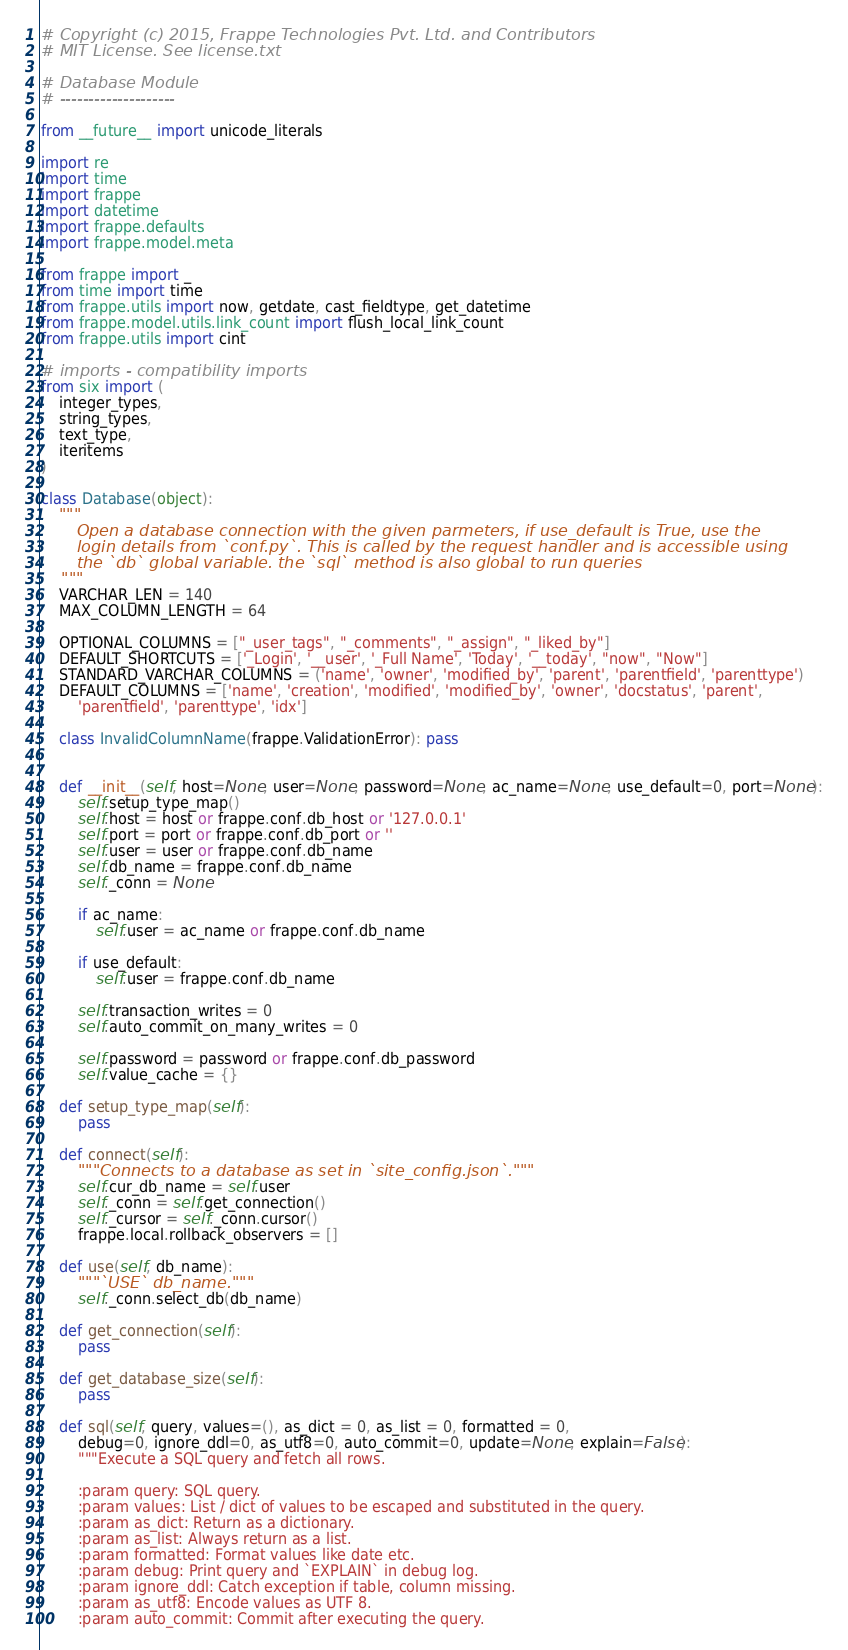Convert code to text. <code><loc_0><loc_0><loc_500><loc_500><_Python_># Copyright (c) 2015, Frappe Technologies Pvt. Ltd. and Contributors
# MIT License. See license.txt

# Database Module
# --------------------

from __future__ import unicode_literals

import re
import time
import frappe
import datetime
import frappe.defaults
import frappe.model.meta

from frappe import _
from time import time
from frappe.utils import now, getdate, cast_fieldtype, get_datetime
from frappe.model.utils.link_count import flush_local_link_count
from frappe.utils import cint

# imports - compatibility imports
from six import (
	integer_types,
	string_types,
	text_type,
	iteritems
)

class Database(object):
	"""
	   Open a database connection with the given parmeters, if use_default is True, use the
	   login details from `conf.py`. This is called by the request handler and is accessible using
	   the `db` global variable. the `sql` method is also global to run queries
	"""
	VARCHAR_LEN = 140
	MAX_COLUMN_LENGTH = 64

	OPTIONAL_COLUMNS = ["_user_tags", "_comments", "_assign", "_liked_by"]
	DEFAULT_SHORTCUTS = ['_Login', '__user', '_Full Name', 'Today', '__today', "now", "Now"]
	STANDARD_VARCHAR_COLUMNS = ('name', 'owner', 'modified_by', 'parent', 'parentfield', 'parenttype')
	DEFAULT_COLUMNS = ['name', 'creation', 'modified', 'modified_by', 'owner', 'docstatus', 'parent',
		'parentfield', 'parenttype', 'idx']

	class InvalidColumnName(frappe.ValidationError): pass


	def __init__(self, host=None, user=None, password=None, ac_name=None, use_default=0, port=None):
		self.setup_type_map()
		self.host = host or frappe.conf.db_host or '127.0.0.1'
		self.port = port or frappe.conf.db_port or ''
		self.user = user or frappe.conf.db_name
		self.db_name = frappe.conf.db_name
		self._conn = None

		if ac_name:
			self.user = ac_name or frappe.conf.db_name

		if use_default:
			self.user = frappe.conf.db_name

		self.transaction_writes = 0
		self.auto_commit_on_many_writes = 0

		self.password = password or frappe.conf.db_password
		self.value_cache = {}

	def setup_type_map(self):
		pass

	def connect(self):
		"""Connects to a database as set in `site_config.json`."""
		self.cur_db_name = self.user
		self._conn = self.get_connection()
		self._cursor = self._conn.cursor()
		frappe.local.rollback_observers = []

	def use(self, db_name):
		"""`USE` db_name."""
		self._conn.select_db(db_name)

	def get_connection(self):
		pass

	def get_database_size(self):
		pass

	def sql(self, query, values=(), as_dict = 0, as_list = 0, formatted = 0,
		debug=0, ignore_ddl=0, as_utf8=0, auto_commit=0, update=None, explain=False):
		"""Execute a SQL query and fetch all rows.

		:param query: SQL query.
		:param values: List / dict of values to be escaped and substituted in the query.
		:param as_dict: Return as a dictionary.
		:param as_list: Always return as a list.
		:param formatted: Format values like date etc.
		:param debug: Print query and `EXPLAIN` in debug log.
		:param ignore_ddl: Catch exception if table, column missing.
		:param as_utf8: Encode values as UTF 8.
		:param auto_commit: Commit after executing the query.</code> 